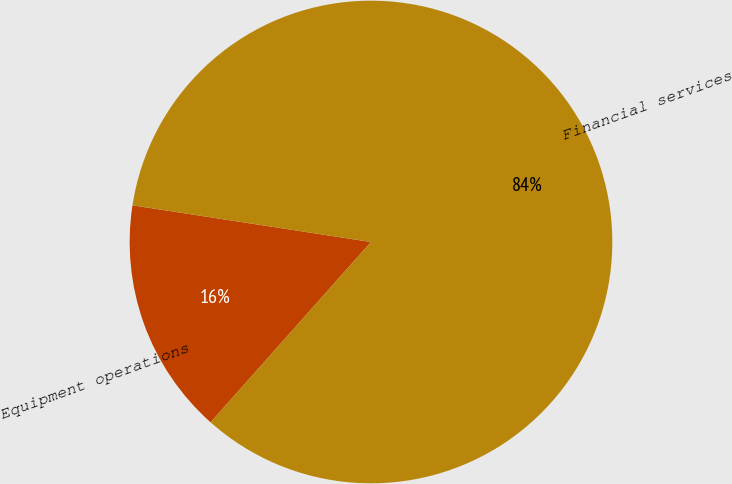<chart> <loc_0><loc_0><loc_500><loc_500><pie_chart><fcel>Equipment operations<fcel>Financial services<nl><fcel>15.86%<fcel>84.14%<nl></chart> 